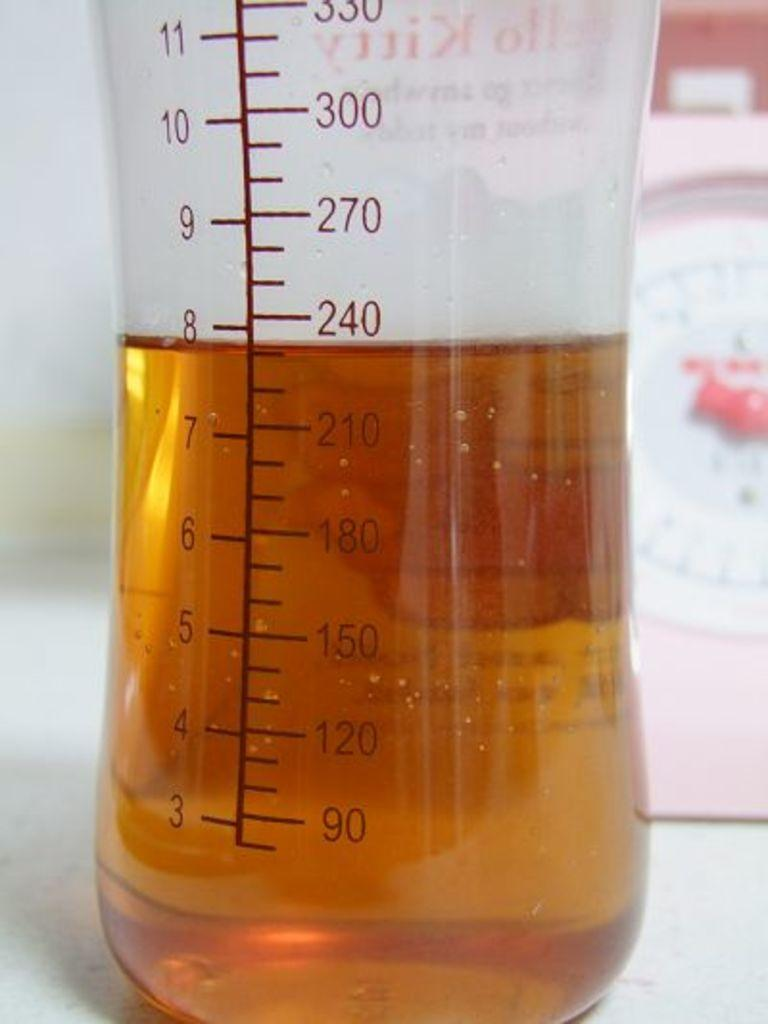<image>
Provide a brief description of the given image. A glass measuring cup is filled to nearly the 8 tick with golden colored liquid. 